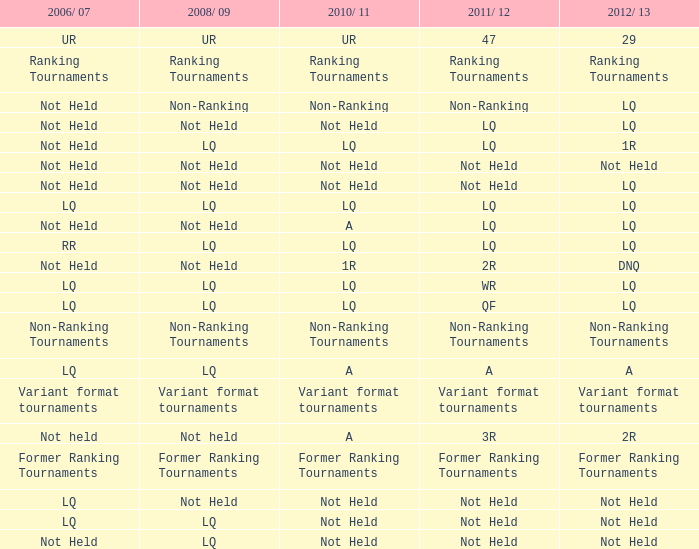What is 2006/07, when 2011/12 is considered lq, and when 2010/11 is regarded as lq? Not Held, LQ, RR. 